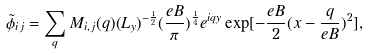<formula> <loc_0><loc_0><loc_500><loc_500>\tilde { \phi } _ { i j } = \sum _ { q } M _ { i , j } ( q ) ( L _ { y } ) ^ { - \frac { 1 } { 2 } } ( \frac { e B } { \pi } ) ^ { \frac { 1 } { 4 } } e ^ { i q y } \exp [ - \frac { e B } { 2 } ( x - \frac { q } { e B } ) ^ { 2 } ] ,</formula> 